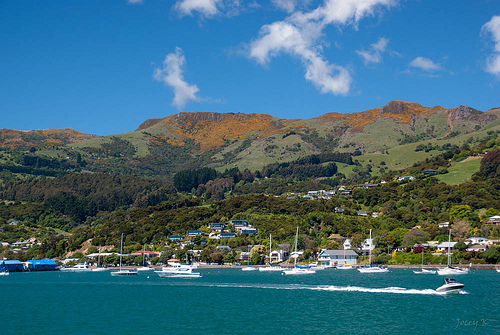<image>
Is the boat to the left of the house? No. The boat is not to the left of the house. From this viewpoint, they have a different horizontal relationship. 